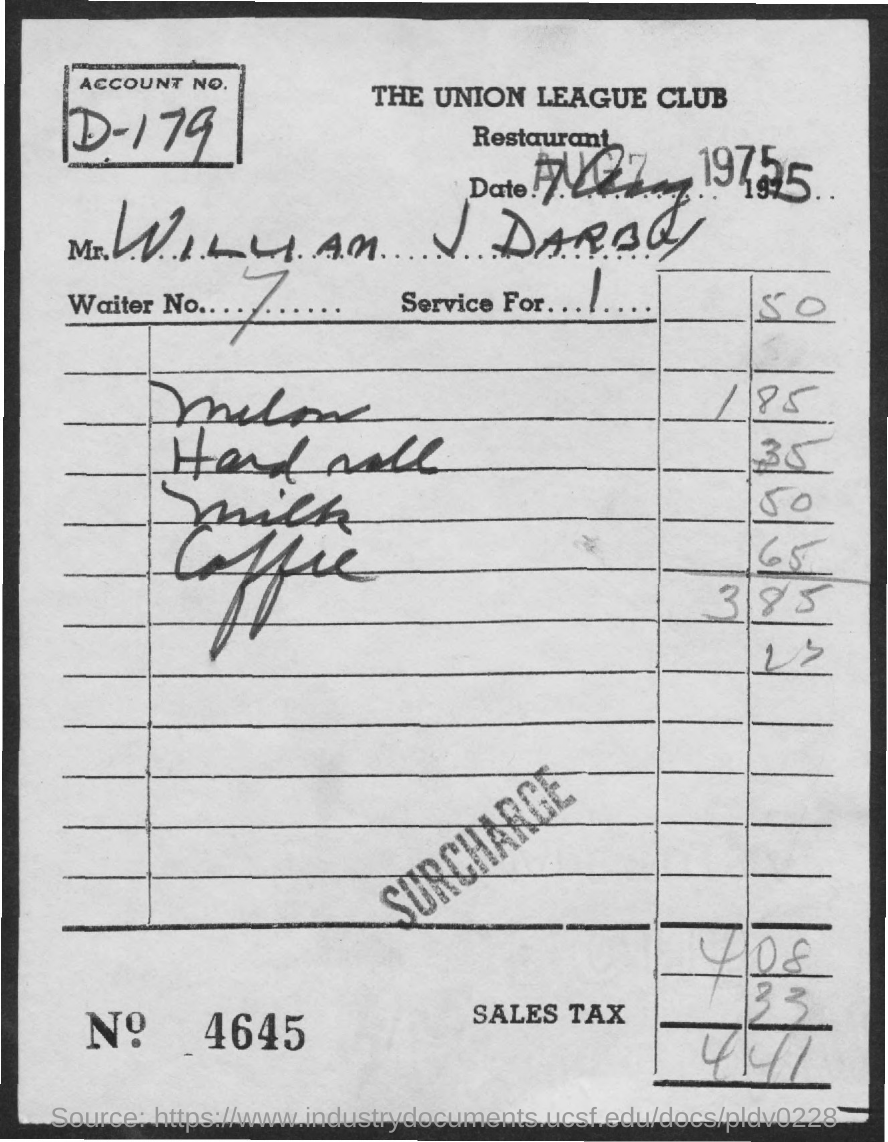What is the account no.?
Provide a succinct answer. D-179. What is the waiter no.?
Your answer should be compact. 7. What is the bill no.?
Your answer should be very brief. 4645. What is the amount of sales tax?
Provide a succinct answer. 33. What is the total amount?
Give a very brief answer. 441. 